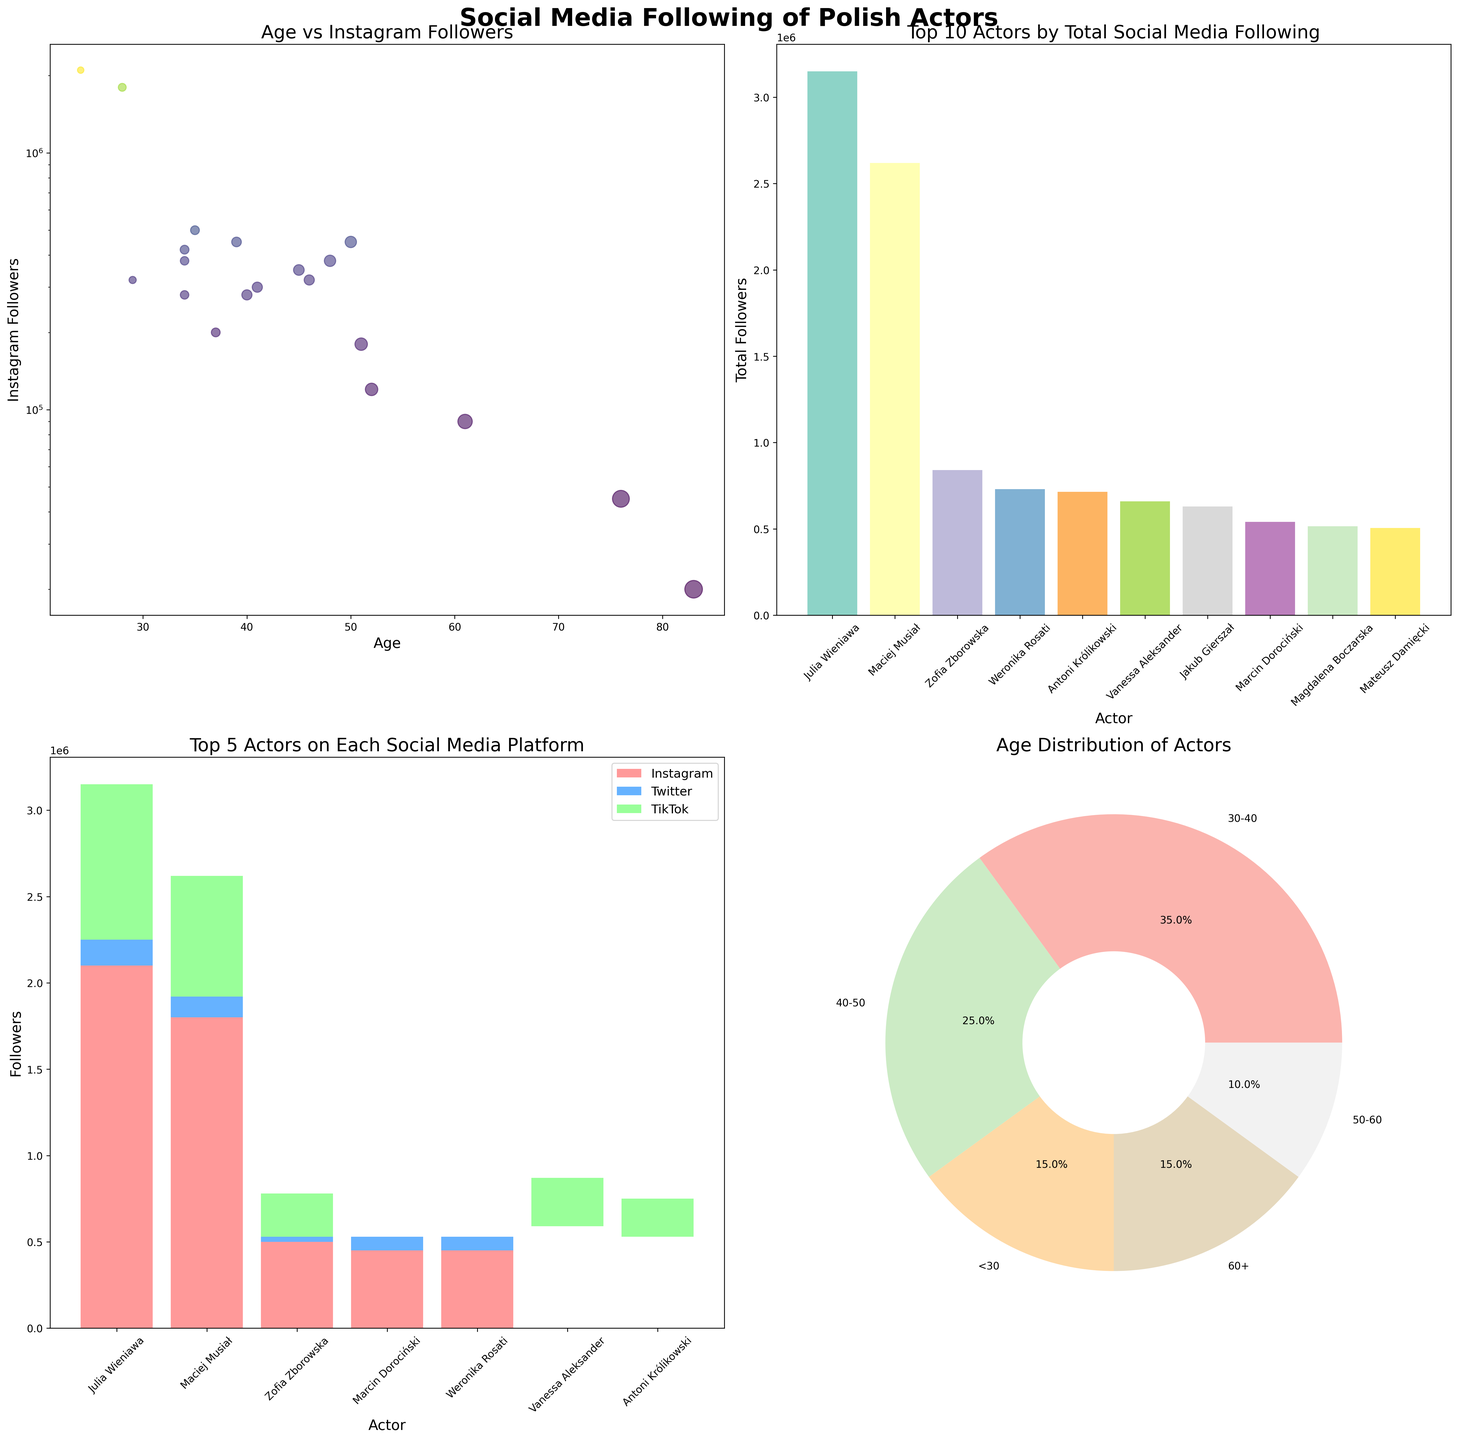Which actor has the highest Instagram followers? In the scatter plot "Age vs Instagram Followers," the actor with the largest number of Instagram followers is evident by the highest vertical position on the y-axis. This highest point corresponds to the figure of 2,100,000 followers which belongs to Julia Wieniawa.
Answer: Julia Wieniawa How does the Instagram following of actors with ages less than 30 compare to those above 60? By examining the scatter plot "Age vs Instagram Followers," actors under 30, like Julia Wieniawa and Maciej Musiał, have very high Instagram follower counts compared to the older actors above 60, such as Andrzej Seweryn and Janusz Gajos, who have relatively lower counts.
Answer: Younger actors have significantly higher Instagram followers than older actors Which actors are in the top 5 on each social media platform? Refer to the stacked bar chart "Top 5 Actors on Each Social Media Platform." The chart shows Instagram (red), Twitter (blue), and TikTok (green) followers for the top 5 actors on each platform, identifying specific actors like Julia Wieniawa, Maciej Musiał, and Zofia Zborowska.
Answer: Julia Wieniawa, Maciej Musiał, Zofia Zborowska, Antoni Królikowski, Vanessa Aleksander What is the distribution of actors across different age groups? The pie chart "Age Distribution of Actors" segments the actors into age groups: <30, 30-40, 40-50, 50-60, and 60+. Examining the pie slices gives the percentage breakdown among these age categories.
Answer: The distribution is: <30 (10.5%), 30-40 (31.6%), 40-50 (21.1%), 50-60 (15.8%), 60+ (21.1%) Which actor has the highest total social media following, and how is it distributed across platforms? In the bar plot "Top 10 Actors by Total Social Media Following," Julia Wieniawa is at the top. Breaking down her total followers across Instagram, Twitter, and TikTok using their respective usual colors gives her the count on each platform.
Answer: Julia Wieniawa; Instagram: 2,100,000, Twitter: 150,000, TikTok: 900,000 What's the relationship between years active and Instagram followers? By observing the scatter plot "Age vs Instagram Followers," actors with larger dots, which represent years active, sometimes have larger Instagram followers, but this is not always the case. For instance, Julia Wieniawa has only 8 years of activity but the most followers.
Answer: No strong correlation Which actor has the widest bar in the stacked bar chart for TikTok followers? In the "Top 5 Actors on Each Social Media Platform" stacked bar chart, the green segment represents TikTok followers. Observing the widest green segment at the top identifies Julia Wieniawa as having the widest bar section for TikTok followers.
Answer: Julia Wieniawa Who are the top three actors with the most Twitter followers, and what are their follower counts? From the stacked bar chart "Top 10 Actors by Total Social Media Following," identify the top three actors with the largest blue segment representing Twitter followers. These are Maciej Musiał, Zofia Zborowska, and Julia Wieniawa; their counts can be read from the chart.
Answer: Maciej Musiał: 120,000, Zofia Zborowska: 90,000, Julia Wieniawa: 150,000 